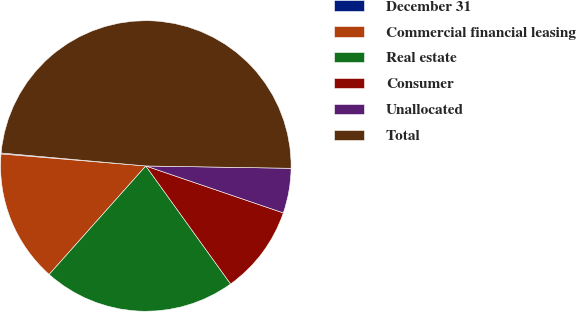Convert chart to OTSL. <chart><loc_0><loc_0><loc_500><loc_500><pie_chart><fcel>December 31<fcel>Commercial financial leasing<fcel>Real estate<fcel>Consumer<fcel>Unallocated<fcel>Total<nl><fcel>0.11%<fcel>14.73%<fcel>21.5%<fcel>9.85%<fcel>4.98%<fcel>48.83%<nl></chart> 